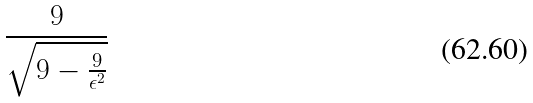Convert formula to latex. <formula><loc_0><loc_0><loc_500><loc_500>\frac { 9 } { \sqrt { 9 - \frac { 9 } { \epsilon ^ { 2 } } } }</formula> 